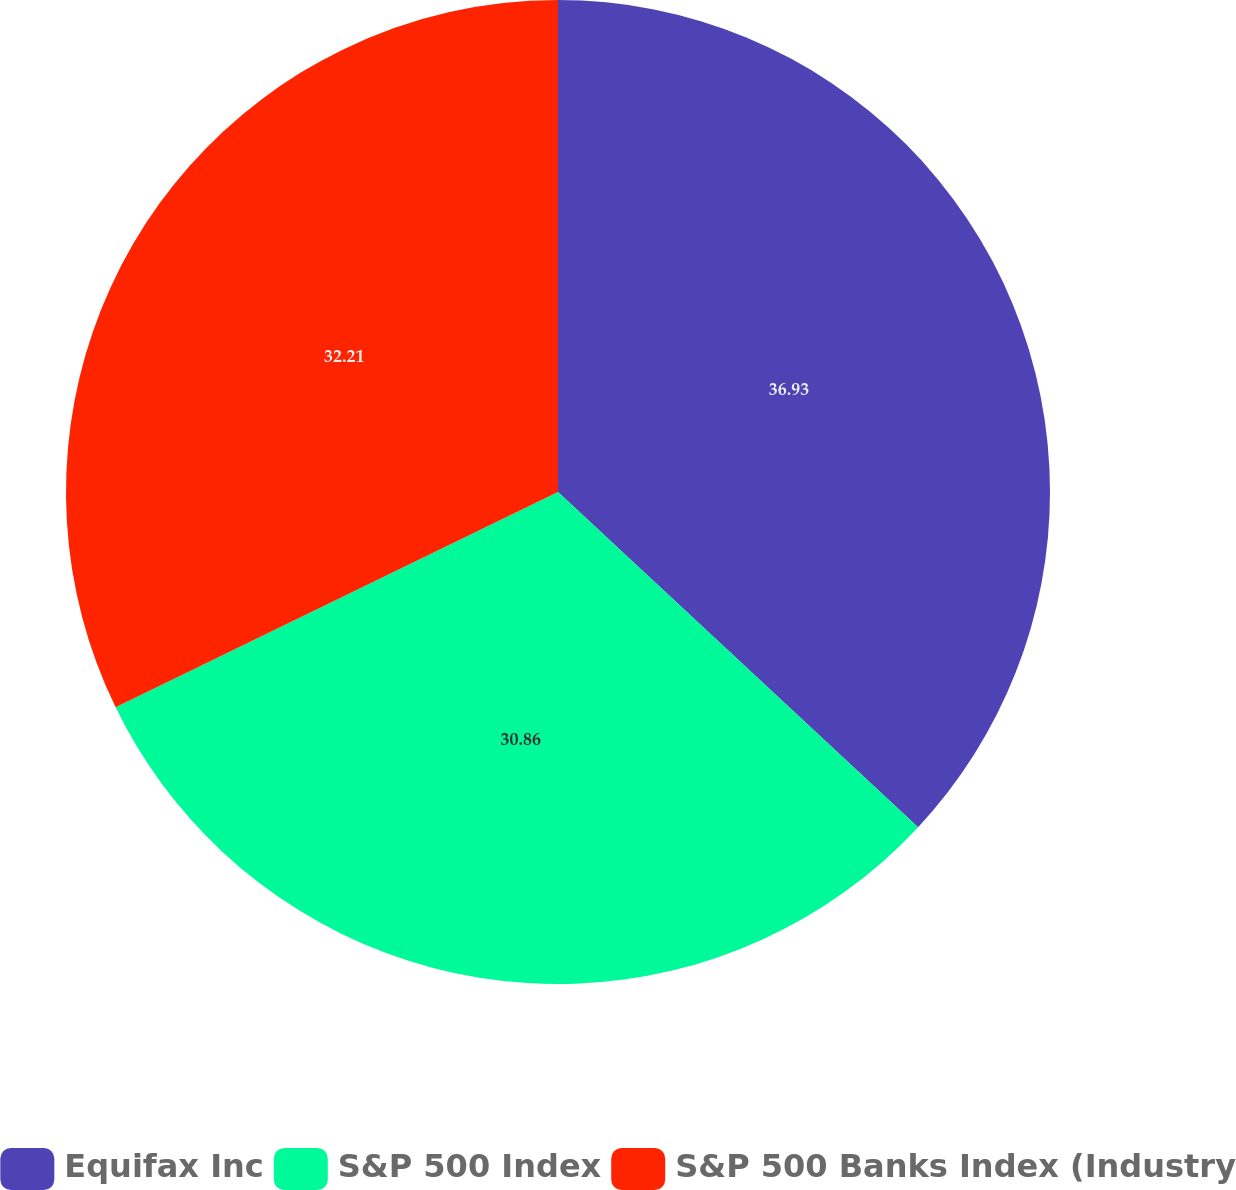Convert chart. <chart><loc_0><loc_0><loc_500><loc_500><pie_chart><fcel>Equifax Inc<fcel>S&P 500 Index<fcel>S&P 500 Banks Index (Industry<nl><fcel>36.93%<fcel>30.86%<fcel>32.21%<nl></chart> 